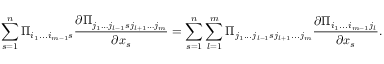Convert formula to latex. <formula><loc_0><loc_0><loc_500><loc_500>\sum _ { s = 1 } ^ { n } \Pi _ { i _ { 1 } \dots i _ { m - 1 } s } \frac { \partial \Pi _ { j _ { 1 } \dots j _ { l - 1 } s j _ { l + 1 } \dots j _ { m } } } { \partial x _ { s } } = \sum _ { s = 1 } ^ { n } \sum _ { l = 1 } ^ { m } \Pi _ { j _ { 1 } \dots j _ { l - 1 } s j _ { l + 1 } \dots j _ { m } } \frac { \partial \Pi _ { i _ { 1 } \dots i _ { m - 1 } j _ { l } } } { \partial x _ { s } } .</formula> 